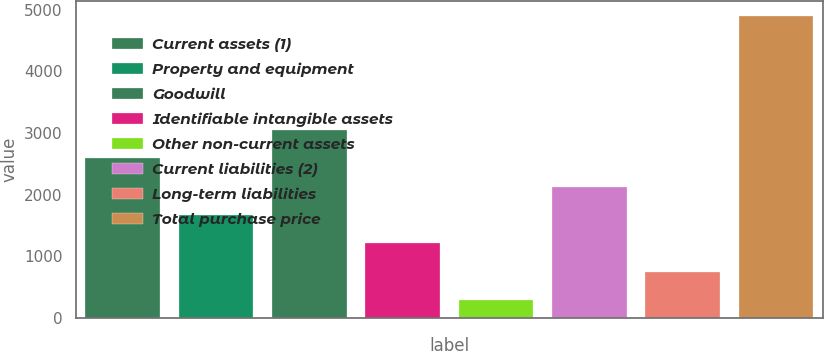Convert chart. <chart><loc_0><loc_0><loc_500><loc_500><bar_chart><fcel>Current assets (1)<fcel>Property and equipment<fcel>Goodwill<fcel>Identifiable intangible assets<fcel>Other non-current assets<fcel>Current liabilities (2)<fcel>Long-term liabilities<fcel>Total purchase price<nl><fcel>2591.5<fcel>1670.5<fcel>3052<fcel>1210<fcel>289<fcel>2131<fcel>749.5<fcel>4894<nl></chart> 